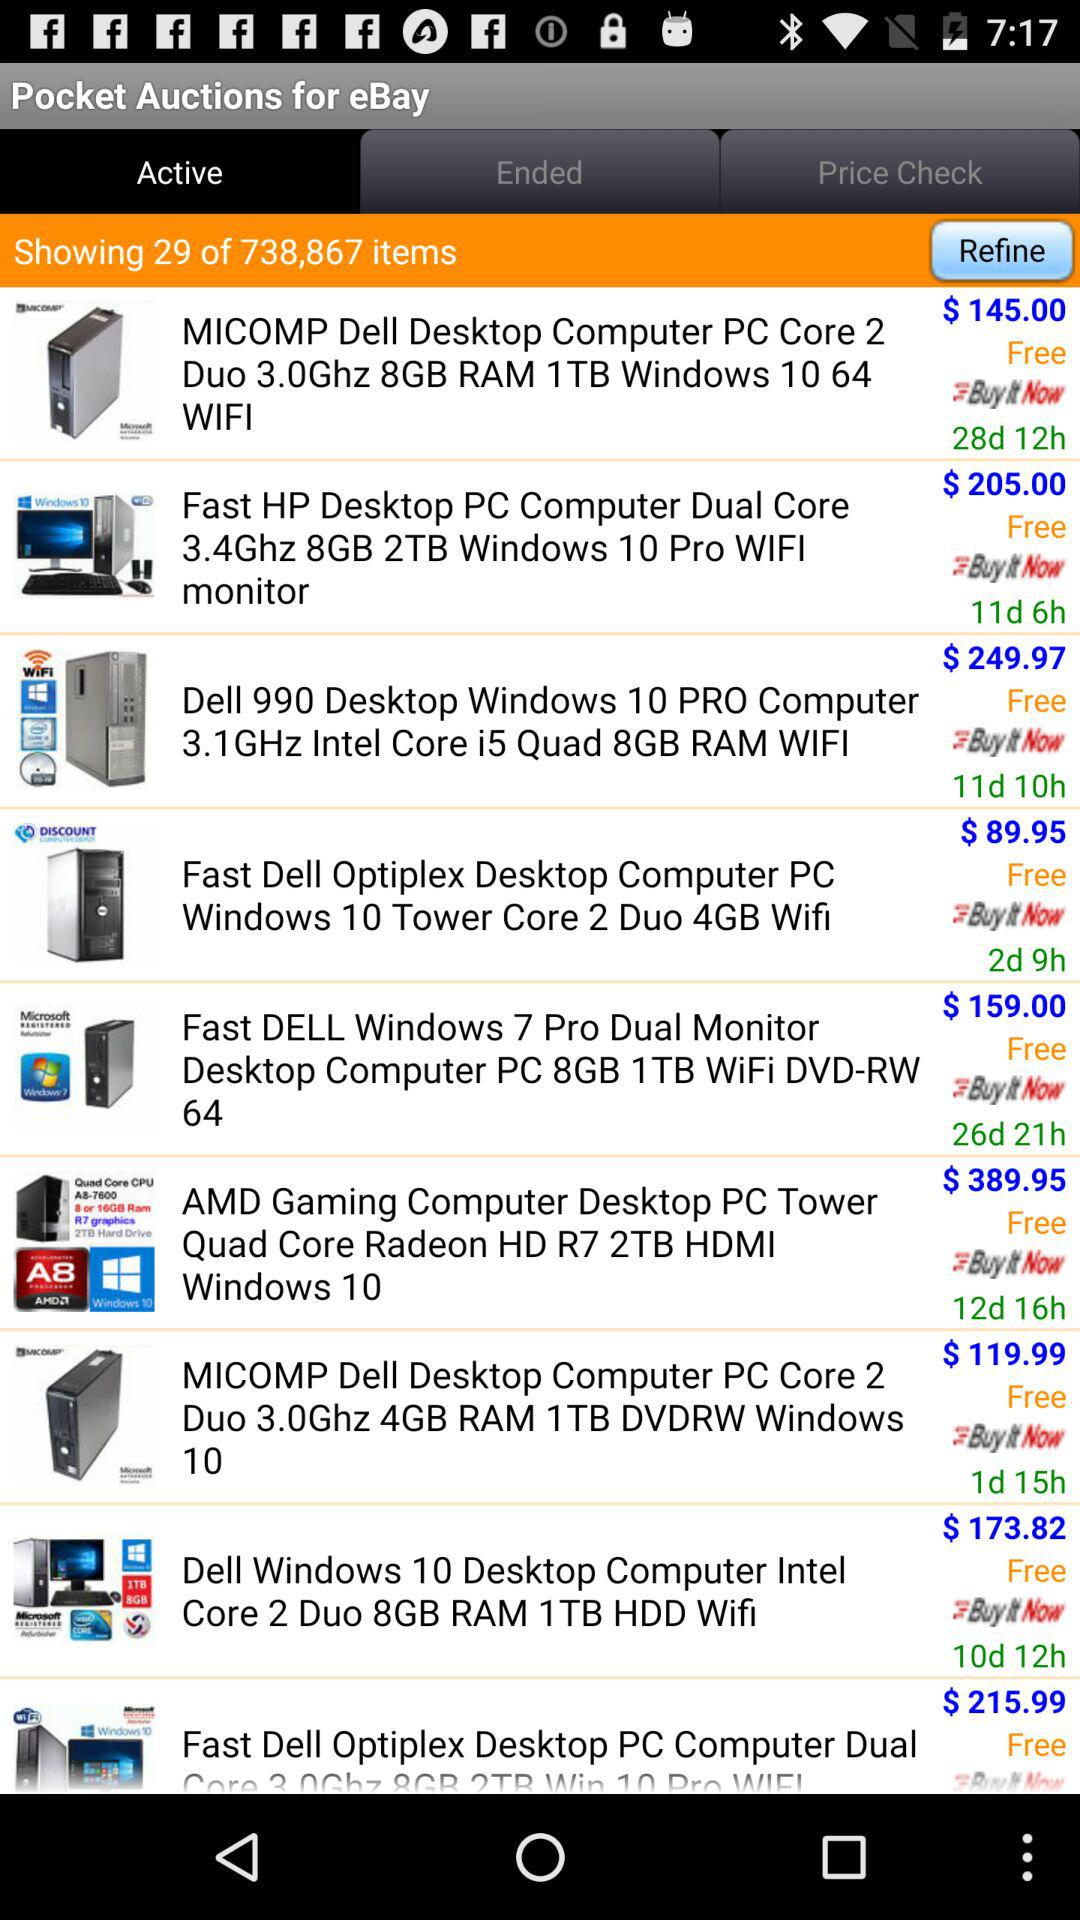Which item has the highest price?
Answer the question using a single word or phrase. AMD Gaming Computer Desktop PC Tower Quad Core Radeon HD R7 2TB HDMI Windows 10 